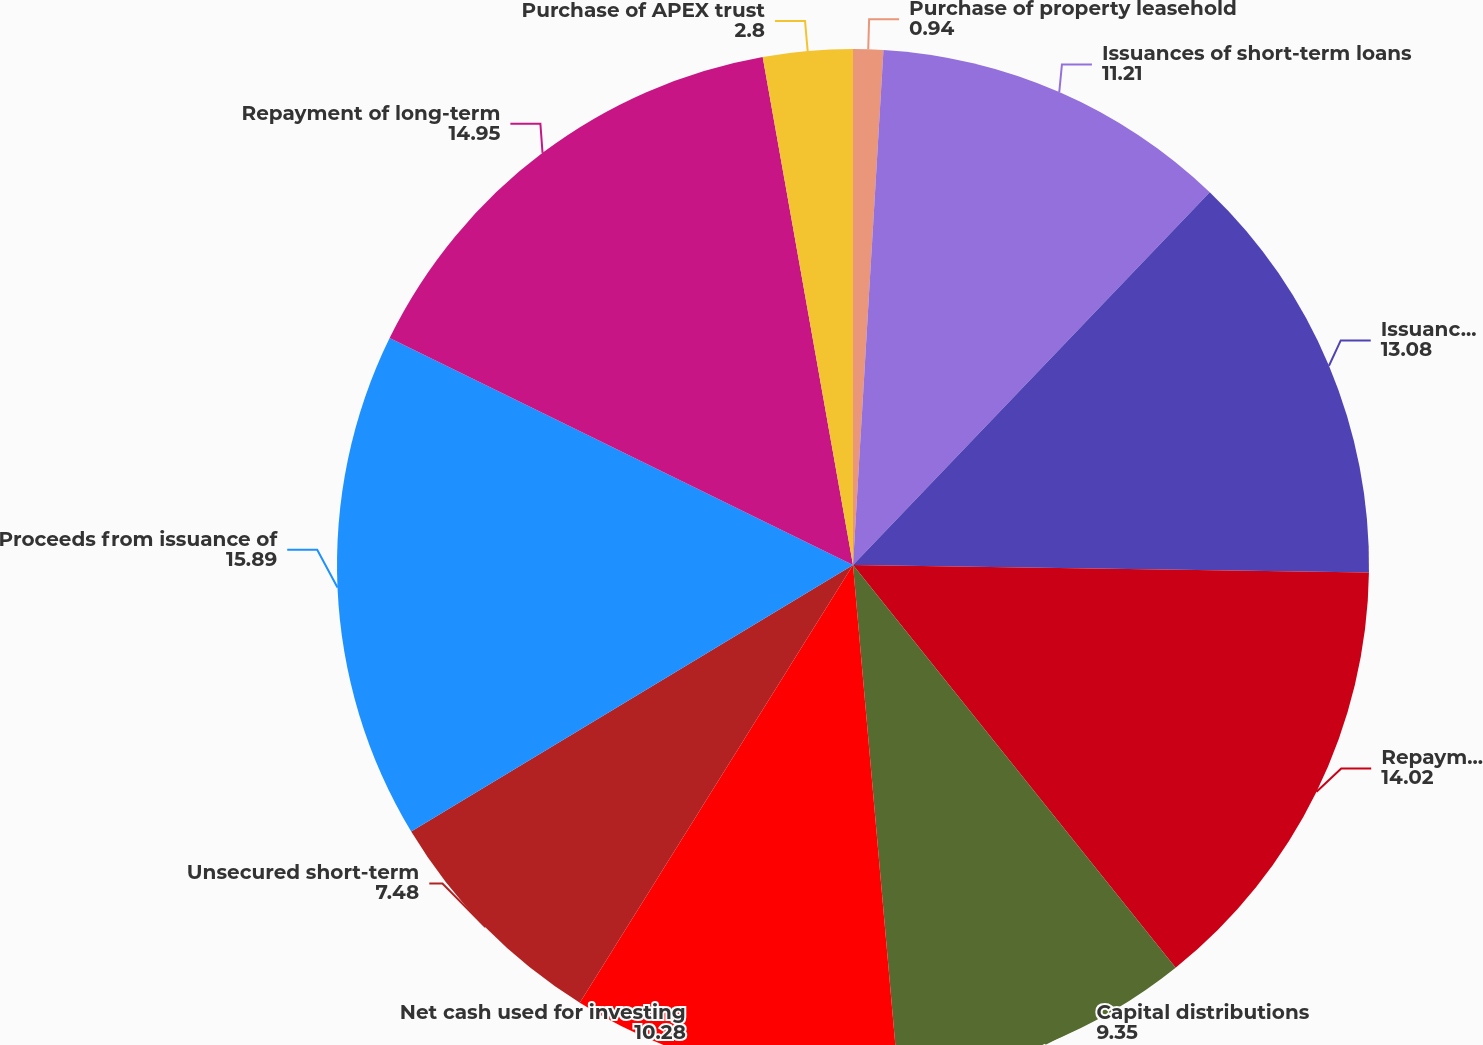<chart> <loc_0><loc_0><loc_500><loc_500><pie_chart><fcel>Purchase of property leasehold<fcel>Issuances of short-term loans<fcel>Issuance of term loans to<fcel>Repayments of term loans by<fcel>Capital distributions<fcel>Net cash used for investing<fcel>Unsecured short-term<fcel>Proceeds from issuance of<fcel>Repayment of long-term<fcel>Purchase of APEX trust<nl><fcel>0.94%<fcel>11.21%<fcel>13.08%<fcel>14.02%<fcel>9.35%<fcel>10.28%<fcel>7.48%<fcel>15.89%<fcel>14.95%<fcel>2.8%<nl></chart> 